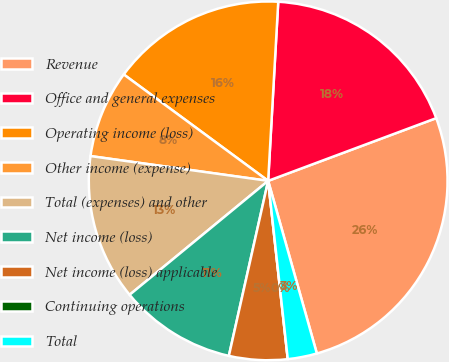Convert chart. <chart><loc_0><loc_0><loc_500><loc_500><pie_chart><fcel>Revenue<fcel>Office and general expenses<fcel>Operating income (loss)<fcel>Other income (expense)<fcel>Total (expenses) and other<fcel>Net income (loss)<fcel>Net income (loss) applicable<fcel>Continuing operations<fcel>Total<nl><fcel>26.31%<fcel>18.42%<fcel>15.79%<fcel>7.9%<fcel>13.16%<fcel>10.53%<fcel>5.26%<fcel>0.0%<fcel>2.63%<nl></chart> 